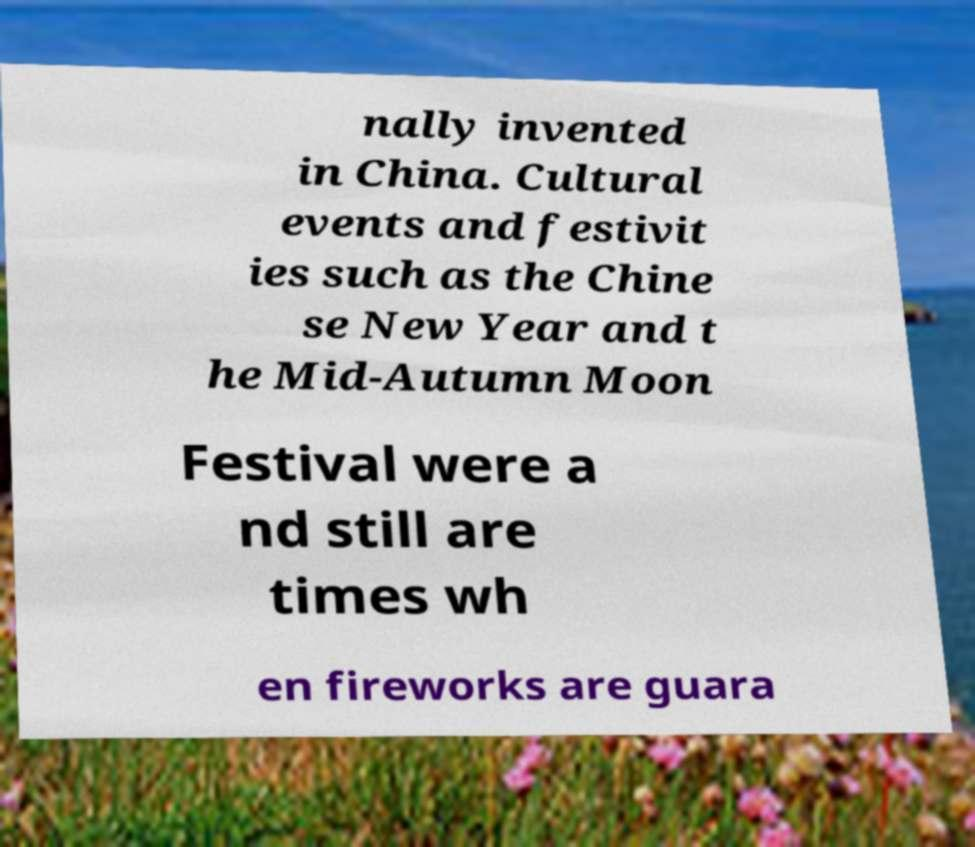For documentation purposes, I need the text within this image transcribed. Could you provide that? nally invented in China. Cultural events and festivit ies such as the Chine se New Year and t he Mid-Autumn Moon Festival were a nd still are times wh en fireworks are guara 